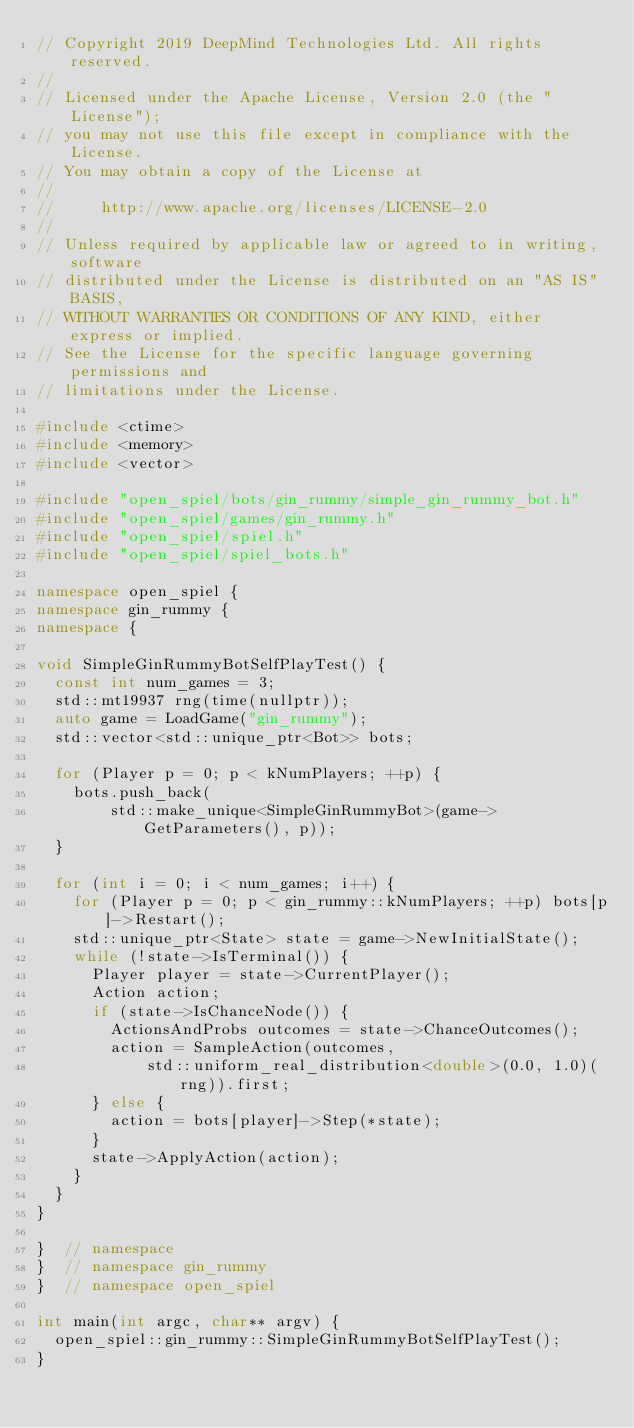<code> <loc_0><loc_0><loc_500><loc_500><_C++_>// Copyright 2019 DeepMind Technologies Ltd. All rights reserved.
//
// Licensed under the Apache License, Version 2.0 (the "License");
// you may not use this file except in compliance with the License.
// You may obtain a copy of the License at
//
//     http://www.apache.org/licenses/LICENSE-2.0
//
// Unless required by applicable law or agreed to in writing, software
// distributed under the License is distributed on an "AS IS" BASIS,
// WITHOUT WARRANTIES OR CONDITIONS OF ANY KIND, either express or implied.
// See the License for the specific language governing permissions and
// limitations under the License.

#include <ctime>
#include <memory>
#include <vector>

#include "open_spiel/bots/gin_rummy/simple_gin_rummy_bot.h"
#include "open_spiel/games/gin_rummy.h"
#include "open_spiel/spiel.h"
#include "open_spiel/spiel_bots.h"

namespace open_spiel {
namespace gin_rummy {
namespace {

void SimpleGinRummyBotSelfPlayTest() {
  const int num_games = 3;
  std::mt19937 rng(time(nullptr));
  auto game = LoadGame("gin_rummy");
  std::vector<std::unique_ptr<Bot>> bots;

  for (Player p = 0; p < kNumPlayers; ++p) {
    bots.push_back(
        std::make_unique<SimpleGinRummyBot>(game->GetParameters(), p));
  }

  for (int i = 0; i < num_games; i++) {
    for (Player p = 0; p < gin_rummy::kNumPlayers; ++p) bots[p]->Restart();
    std::unique_ptr<State> state = game->NewInitialState();
    while (!state->IsTerminal()) {
      Player player = state->CurrentPlayer();
      Action action;
      if (state->IsChanceNode()) {
        ActionsAndProbs outcomes = state->ChanceOutcomes();
        action = SampleAction(outcomes,
            std::uniform_real_distribution<double>(0.0, 1.0)(rng)).first;
      } else {
        action = bots[player]->Step(*state);
      }
      state->ApplyAction(action);
    }
  }
}

}  // namespace
}  // namespace gin_rummy
}  // namespace open_spiel

int main(int argc, char** argv) {
  open_spiel::gin_rummy::SimpleGinRummyBotSelfPlayTest();
}
</code> 